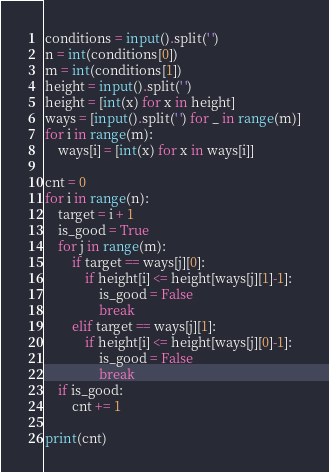Convert code to text. <code><loc_0><loc_0><loc_500><loc_500><_Python_>conditions = input().split(' ')
n = int(conditions[0])
m = int(conditions[1])
height = input().split(' ')
height = [int(x) for x in height]
ways = [input().split(' ') for _ in range(m)]
for i in range(m):
    ways[i] = [int(x) for x in ways[i]]

cnt = 0
for i in range(n):
    target = i + 1
    is_good = True
    for j in range(m):
        if target == ways[j][0]:
            if height[i] <= height[ways[j][1]-1]:
                is_good = False
                break
        elif target == ways[j][1]:
            if height[i] <= height[ways[j][0]-1]:
                is_good = False
                break
    if is_good:
        cnt += 1

print(cnt)</code> 